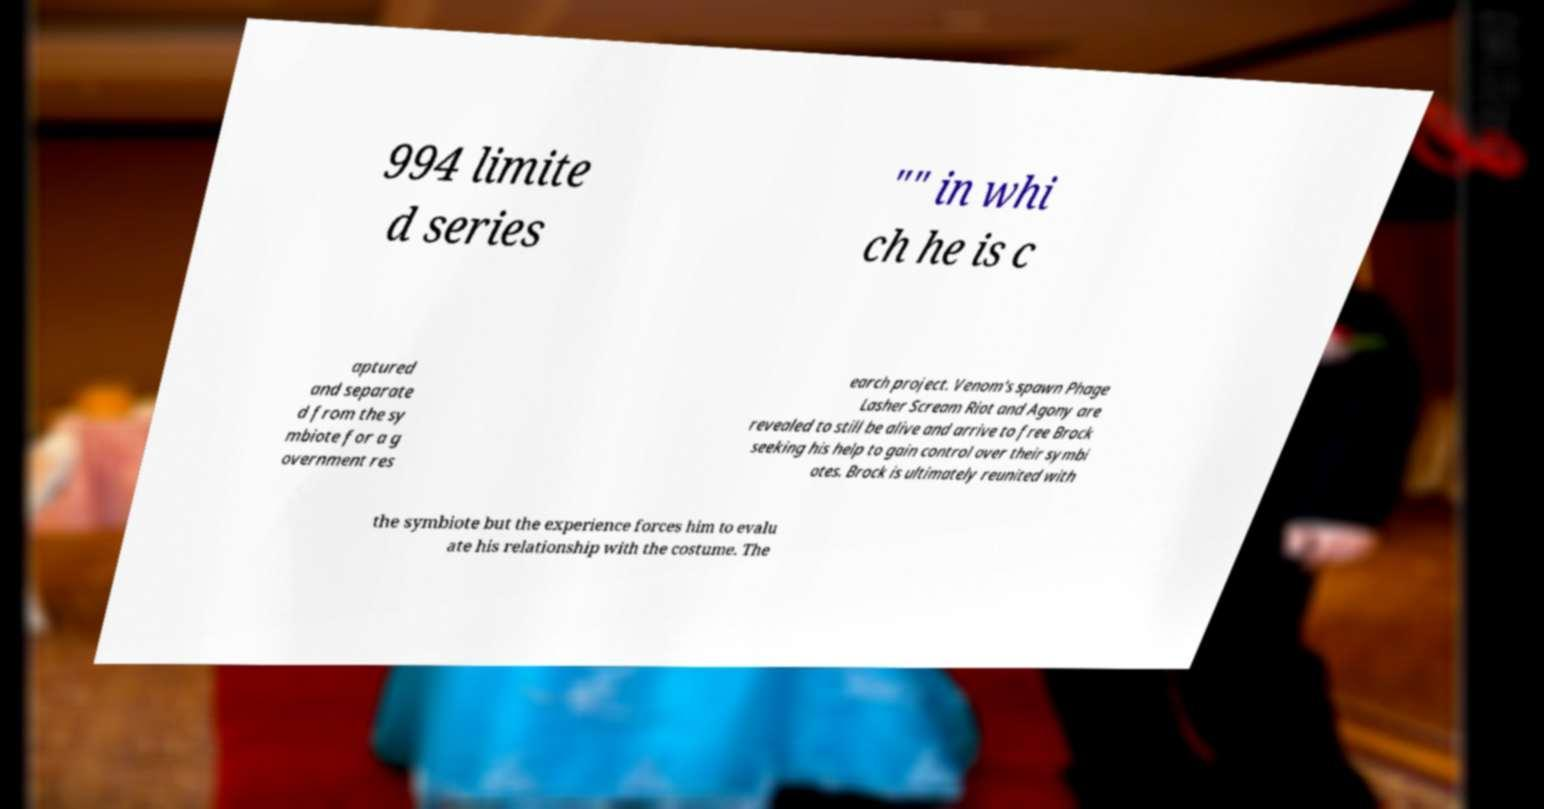Could you assist in decoding the text presented in this image and type it out clearly? 994 limite d series "" in whi ch he is c aptured and separate d from the sy mbiote for a g overnment res earch project. Venom's spawn Phage Lasher Scream Riot and Agony are revealed to still be alive and arrive to free Brock seeking his help to gain control over their symbi otes. Brock is ultimately reunited with the symbiote but the experience forces him to evalu ate his relationship with the costume. The 